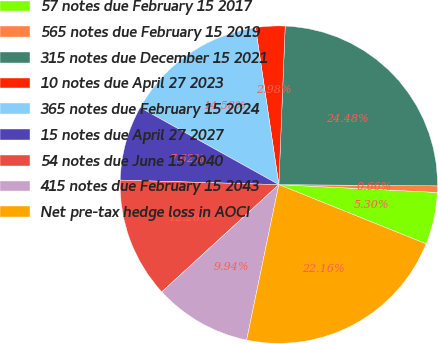Convert chart to OTSL. <chart><loc_0><loc_0><loc_500><loc_500><pie_chart><fcel>57 notes due February 15 2017<fcel>565 notes due February 15 2019<fcel>315 notes due December 15 2021<fcel>10 notes due April 27 2023<fcel>365 notes due February 15 2024<fcel>15 notes due April 27 2027<fcel>54 notes due June 15 2040<fcel>415 notes due February 15 2043<fcel>Net pre-tax hedge loss in AOCI<nl><fcel>5.3%<fcel>0.66%<fcel>24.48%<fcel>2.98%<fcel>14.58%<fcel>7.62%<fcel>12.26%<fcel>9.94%<fcel>22.16%<nl></chart> 